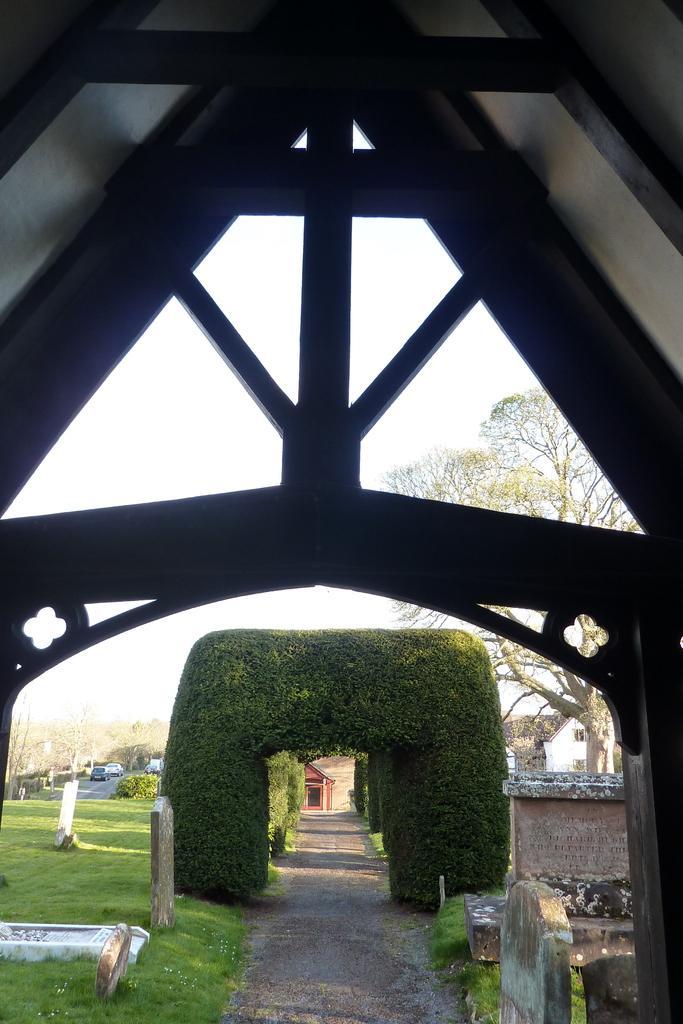How would you summarize this image in a sentence or two? In this image there is a wooden arch at the top. In the background there are so many arches which are made up of leaves. On the left side there is a ground on which there are stones. On the right side there is a building in the background. Beside the building there is a tree. At the bottom there are stones on the ground. In the background we can see the vehicles. 